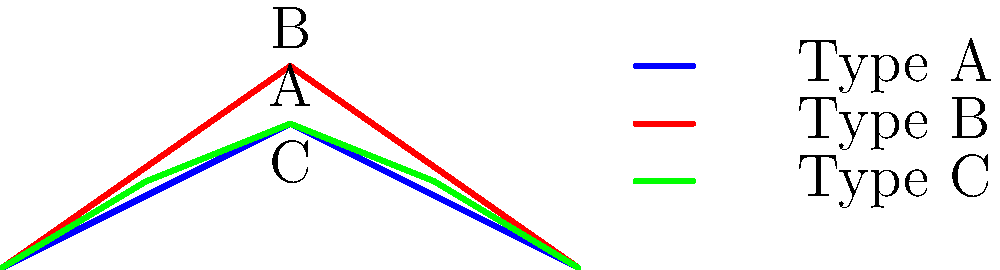In traditional Japanese architecture, which of the three roof truss designs shown above (A, B, or C) would likely provide the greatest structural strength for a large temple hall, and why? To determine which roof truss design provides the greatest structural strength, we need to consider several factors:

1. Triangulation: Triangular shapes are inherently stable and distribute forces efficiently.
2. Load distribution: More connection points help distribute the load more evenly.
3. Pitch: A steeper pitch can help with snow and rain runoff, which is important in many parts of Japan.

Let's analyze each design:

A. Simple triangular truss: Basic design with minimal material use.
B. Steeper triangular truss: Improved pitch for better weather resistance.
C. King post truss: Multiple triangulation points for better load distribution.

Step-by-step analysis:

1. Design A is a basic triangular truss. While stable, it has limited load distribution capabilities.
2. Design B has a steeper pitch, which is beneficial for weather resistance but doesn't significantly improve structural strength.
3. Design C, the king post truss, incorporates multiple triangulation points. This design:
   a) Distributes the load more evenly across the structure
   b) Reduces the stress on individual members
   c) Provides better support for larger spans

4. In traditional Japanese architecture, large temple halls often required substantial roof spans to create open interior spaces.
5. The king post design (C) was commonly used in such structures due to its superior load-bearing capacity and ability to support larger roof areas.

Therefore, based on structural principles and historical usage in Japanese architecture, the king post truss (Design C) would likely provide the greatest structural strength for a large temple hall.
Answer: Design C (King post truss) 